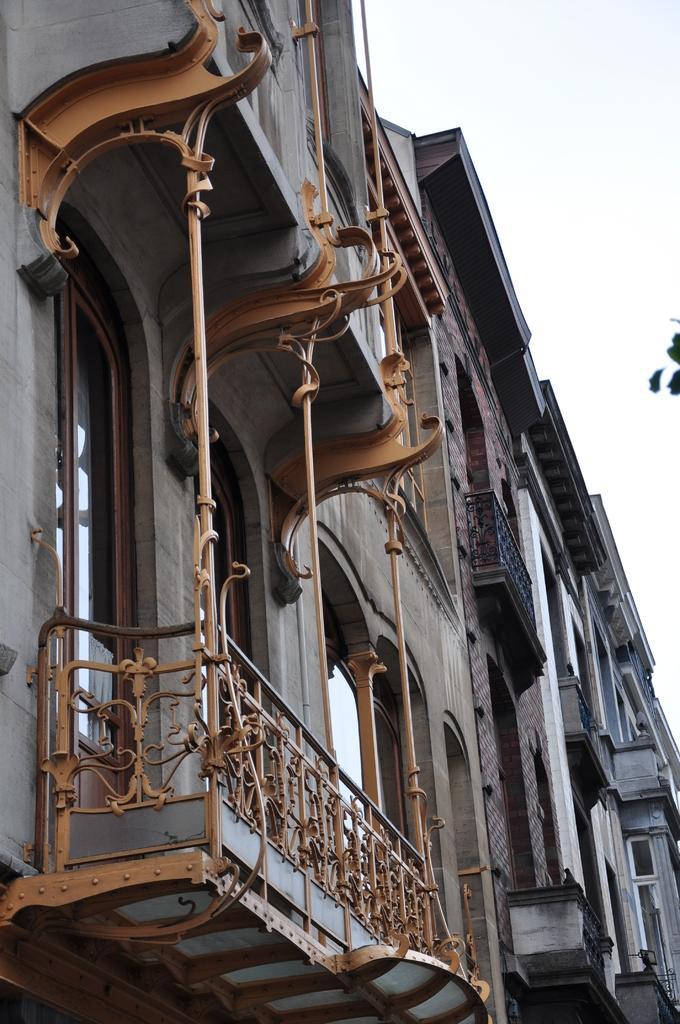Please provide a concise description of this image. In the image I can see two buildings to which there is a balcony. 